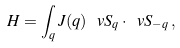Convert formula to latex. <formula><loc_0><loc_0><loc_500><loc_500>H = \int _ { q } J ( { q } ) \, \ v S _ { q } \cdot \ v S _ { - { q } } \, ,</formula> 